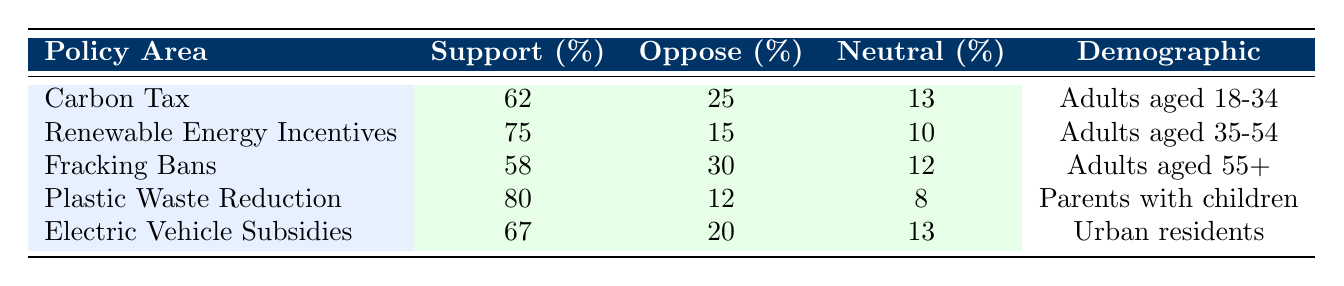What is the support percentage for Plastic Waste Reduction? The table lists the support percentage for Plastic Waste Reduction as 80%.
Answer: 80% Which demographic shows the least support for a policy area, according to the table? The demographic that shows the least support is Adults aged 55+ for Fracking Bans with a support percentage of 58%.
Answer: Adults aged 55+ What is the difference in support percentage between Renewable Energy Incentives and Carbon Tax? The support percentage for Renewable Energy Incentives is 75% and for Carbon Tax, it is 62%. The difference is 75% - 62% = 13%.
Answer: 13% Is there a demographic that has neutral opinions on Plastic Waste Reduction? The table indicates that Parents with children have a neutral percentage of 8%, which suggests that there is a neutral opinion within this demographic.
Answer: Yes What is the average support percentage for all the policies listed in the table? The support percentages are 62%, 75%, 58%, 80%, and 67%. To find the average, we add them: 62% + 75% + 58% + 80% + 67% = 342%. Then, we divide by 5 (the number of data points): 342% / 5 = 68.4%.
Answer: 68.4% Which policy area has the highest oppose percentage, and what is that percentage? The policy area with the highest oppose percentage is Fracking Bans, which has an oppose percentage of 30%.
Answer: Fracking Bans, 30% Are there more respondents who support Electric Vehicle Subsidies than those who oppose it? The support percentage for Electric Vehicle Subsidies is 67% while the oppose percentage is 20%. Since 67% > 20%, this statement is true.
Answer: Yes What is the sum of the neutral percentages for all listed policies? The neutral percentages are 13%, 10%, 12%, 8%, and 13%. The sum is: 13% + 10% + 12% + 8% + 13% = 56%.
Answer: 56% What percentage of Urban residents oppose Electric Vehicle Subsidies? The oppose percentage for Electric Vehicle Subsidies among Urban residents is 20%.
Answer: 20% 